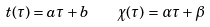<formula> <loc_0><loc_0><loc_500><loc_500>t ( \tau ) = a \tau + b \quad \chi ( \tau ) = \alpha \tau + \beta</formula> 